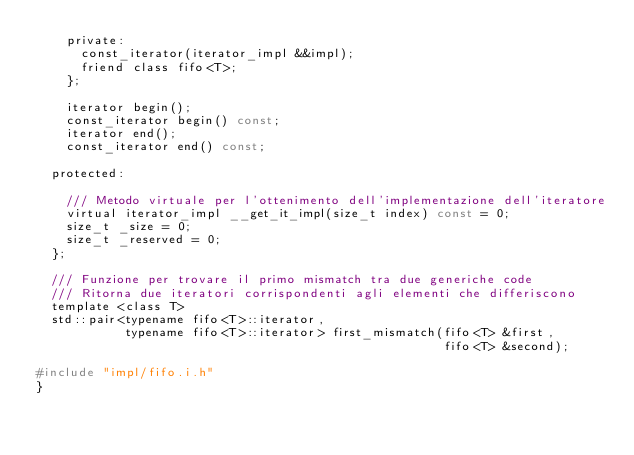<code> <loc_0><loc_0><loc_500><loc_500><_C_>    private:
      const_iterator(iterator_impl &&impl);
      friend class fifo<T>;
    };

    iterator begin();
    const_iterator begin() const;
    iterator end();
    const_iterator end() const;

  protected:

    /// Metodo virtuale per l'ottenimento dell'implementazione dell'iteratore
    virtual iterator_impl __get_it_impl(size_t index) const = 0;
    size_t _size = 0;
    size_t _reserved = 0;
  };

  /// Funzione per trovare il primo mismatch tra due generiche code
  /// Ritorna due iteratori corrispondenti agli elementi che differiscono
  template <class T>
  std::pair<typename fifo<T>::iterator,
            typename fifo<T>::iterator> first_mismatch(fifo<T> &first,
                                                       fifo<T> &second);

#include "impl/fifo.i.h"
}
</code> 